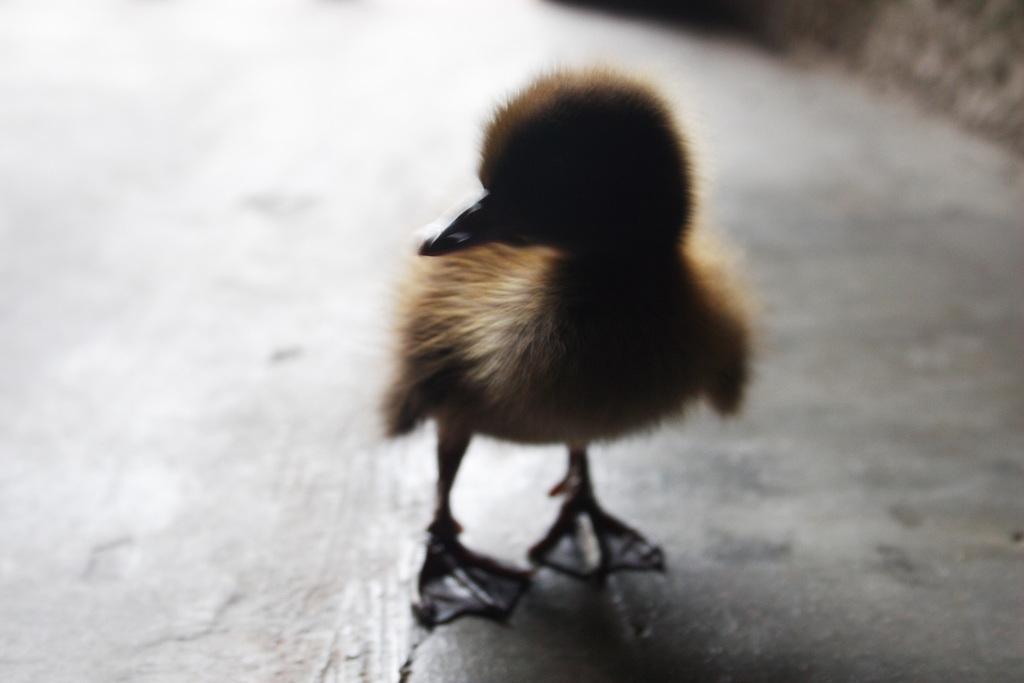Could you give a brief overview of what you see in this image? In this image we can see a chick on the ground. 